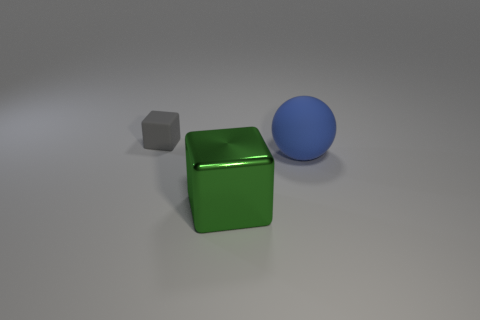Subtract all green cubes. How many cubes are left? 1 Add 3 large yellow cylinders. How many objects exist? 6 Add 3 big objects. How many big objects are left? 5 Add 3 large blue matte objects. How many large blue matte objects exist? 4 Subtract 1 green blocks. How many objects are left? 2 Subtract all spheres. How many objects are left? 2 Subtract all red blocks. Subtract all purple balls. How many blocks are left? 2 Subtract all blue rubber balls. Subtract all big rubber cubes. How many objects are left? 2 